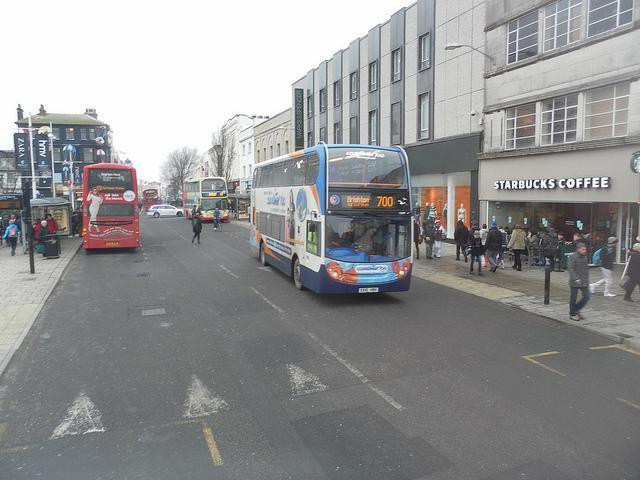How many buses can you see?
Give a very brief answer. 2. 